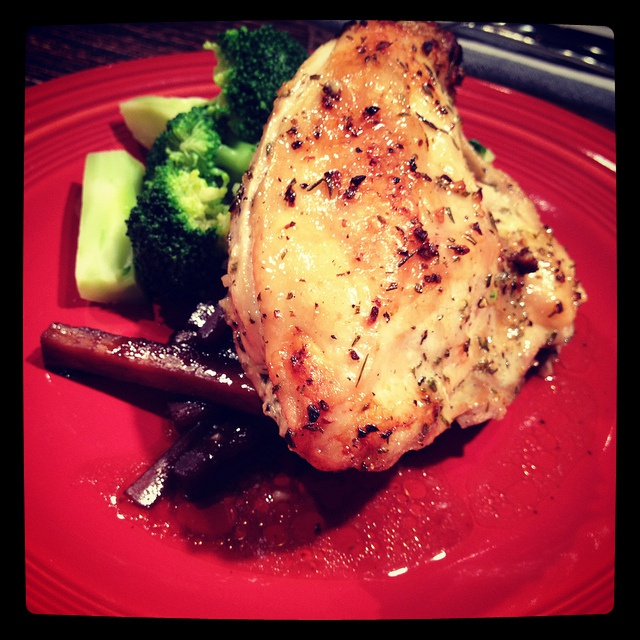Describe the objects in this image and their specific colors. I can see sandwich in black, tan, khaki, and salmon tones, broccoli in black, darkgreen, and green tones, and broccoli in black, khaki, darkgreen, and lightgreen tones in this image. 